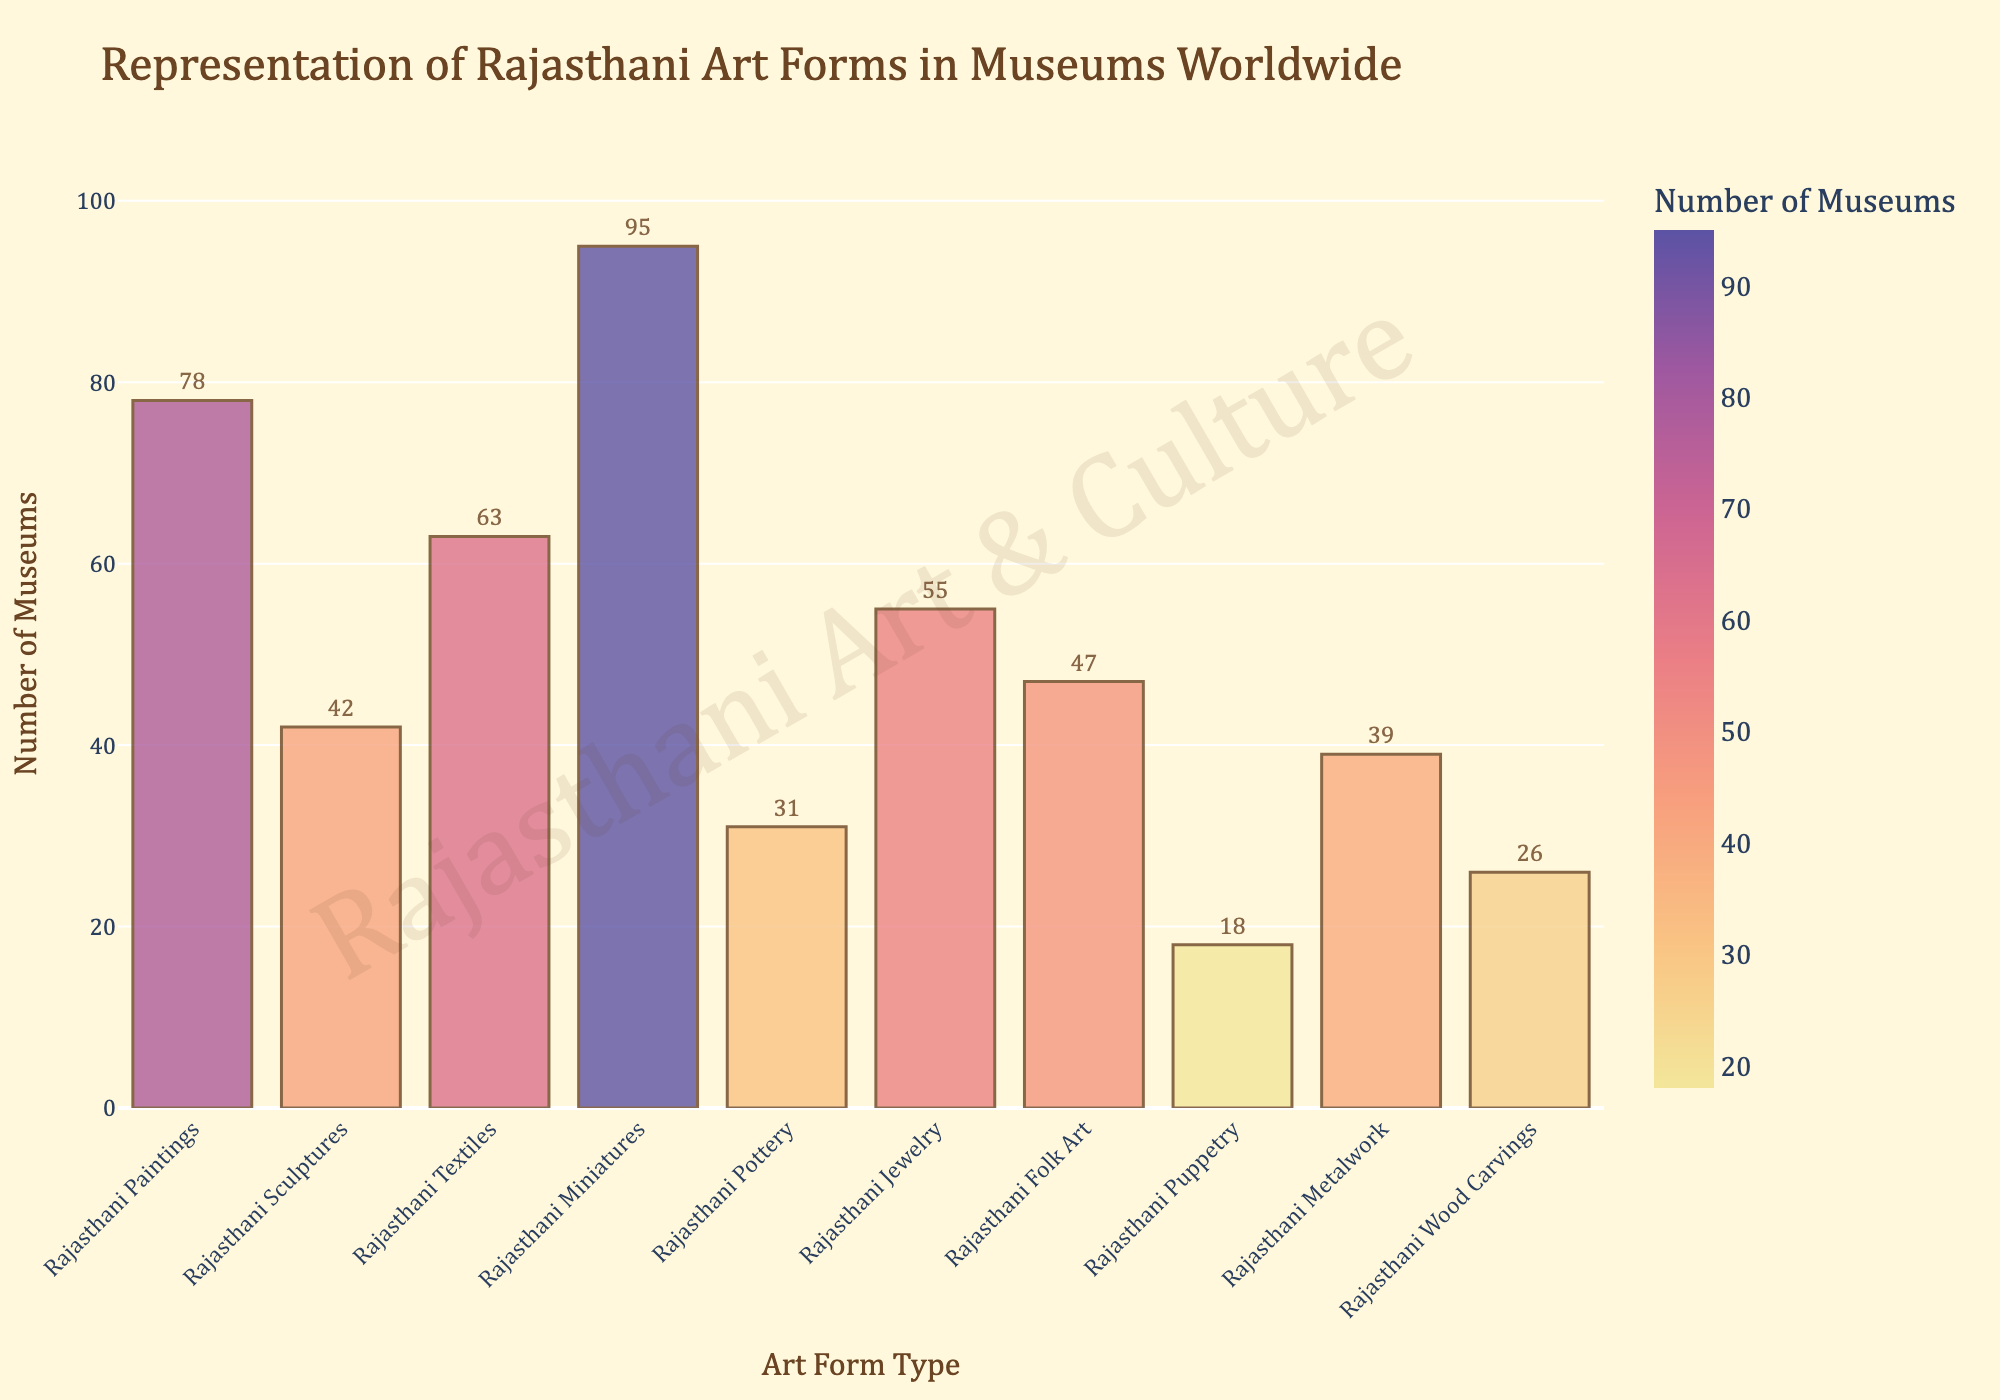Which Rajasthani art form is represented in the most number of museums worldwide? Look for the longest bar in the bar chart which corresponds to the highest 'Number of Museums'. The Rajasthani Miniatures have the longest bar.
Answer: Rajasthani Miniatures Which two Rajasthani art forms combined are represented in the least number of museums? Identify the two shortest bars in the bar chart, which are Rajasthani Puppetry and Rajasthani Pottery, with counts of 18 and 31 respectively. Summing these gives 49.
Answer: Rajasthani Puppetry and Rajasthani Pottery How many more museums represent Rajasthani Paintings compared to Rajasthani Sculptures? Find the 'Number of Museums' for Rajasthani Paintings and Rajasthani Sculptures, which are 78 and 42 respectively. Subtract 42 from 78.
Answer: 36 What is the average number of museums representing Rajasthani Textiles, Rajasthani Jewelry, and Rajasthani Folk Art? Sum the 'Number of Museums' for Rajasthani Textiles (63), Rajasthani Jewelry (55), and Rajasthani Folk Art (47) to get 165. Divide by 3 to find the average.
Answer: 55 How many more museums display Rajasthani Miniatures than Rajasthani Wood Carvings? Identify the bars for Rajasthani Miniatures (95) and Rajasthani Wood Carvings (26), then subtract the two values: 95 - 26.
Answer: 69 Is Rajasthani Metalwork represented in fewer museums than Rajasthani Paintings and Rajasthani Textiles combined? Compare the sum of 'Number of Museums' for Rajasthani Paintings (78) and Rajasthani Textiles (63), which is 141, with 'Number of Museums' for Rajasthani Metalwork (39).
Answer: Yes Arrange Rajasthani Sculptures, Rajasthani Folk Art, and Rajasthani Metalwork in ascending order of their representation in museums. Compare the 'Number of Museums' for each art form: Rajasthani Sculptures (42), Rajasthani Folk Art (47), and Rajasthani Metalwork (39). Order them in ascending order.
Answer: Rajasthani Metalwork, Rajasthani Sculptures, Rajasthani Folk Art What is the total number of museums displaying Rajasthani Pottery and Rajasthani Puppetry? Add the 'Number of Museums' for Rajasthani Pottery (31) and Rajasthani Puppetry (18).
Answer: 49 Which Rajasthani art form has almost twice the number of museums as Rajasthani Jewelry? Rajasthani Jewelry has 55 museums; check for the art form with a 'Number of Museums' close to double 55, which is about 110. None fits exactly, but Rajasthani Miniatures (95) is closest.
Answer: Rajasthani Miniatures 